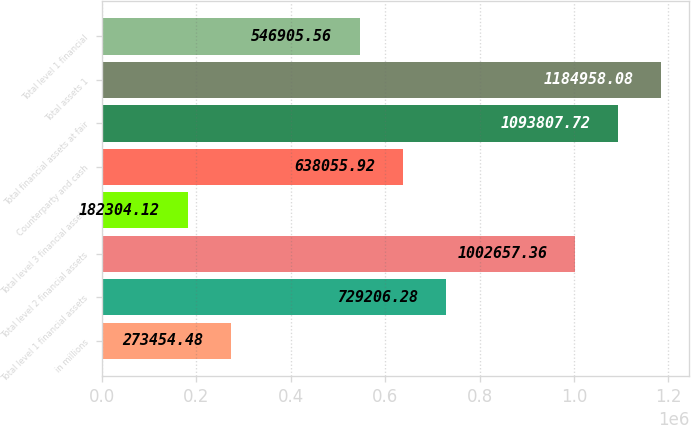Convert chart. <chart><loc_0><loc_0><loc_500><loc_500><bar_chart><fcel>in millions<fcel>Total level 1 financial assets<fcel>Total level 2 financial assets<fcel>Total level 3 financial assets<fcel>Counterparty and cash<fcel>Total financial assets at fair<fcel>Total assets 1<fcel>Total level 1 financial<nl><fcel>273454<fcel>729206<fcel>1.00266e+06<fcel>182304<fcel>638056<fcel>1.09381e+06<fcel>1.18496e+06<fcel>546906<nl></chart> 